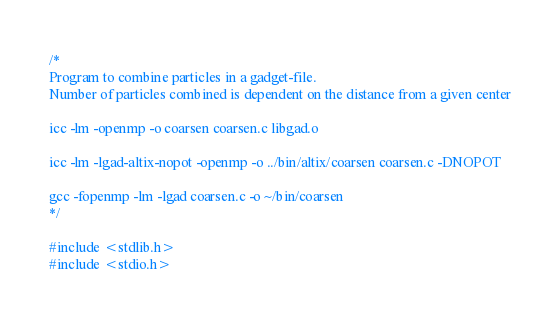Convert code to text. <code><loc_0><loc_0><loc_500><loc_500><_C_>/*
Program to combine particles in a gadget-file. 
Number of particles combined is dependent on the distance from a given center

icc -lm -openmp -o coarsen coarsen.c libgad.o

icc -lm -lgad-altix-nopot -openmp -o ../bin/altix/coarsen coarsen.c -DNOPOT

gcc -fopenmp -lm -lgad coarsen.c -o ~/bin/coarsen
*/

#include <stdlib.h>
#include <stdio.h></code> 